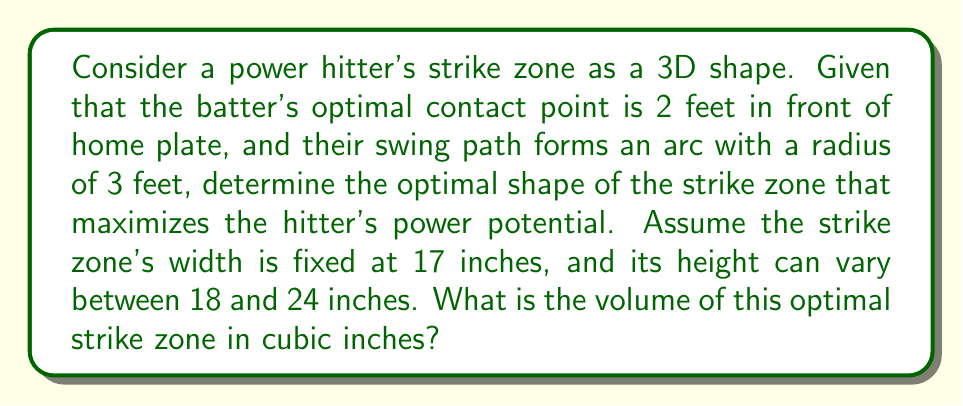Provide a solution to this math problem. To solve this problem, we need to consider the geometry of the swing and how it intersects with the strike zone. Let's break it down step-by-step:

1) The swing path forms an arc. This suggests that the optimal strike zone shape should conform to this arc to maximize contact potential.

2) We can model the strike zone as a segment of a torus (donut shape) that intersects with the swing arc.

3) The inner radius of the torus is 2 feet (distance to optimal contact point), and the tube radius is determined by the height of the strike zone.

4) To maximize power, we want to use the maximum allowed height of 24 inches (2 feet).

5) The width of the strike zone (17 inches) represents the angular section of the torus we're considering.

6) To calculate the volume, we need to find the volume of the toroidal segment:

   $$V = 2\pi^2 R r^2 \left(\frac{\theta}{360^\circ}\right)$$

   Where:
   $R$ = inner radius of the torus (2 feet)
   $r$ = tube radius (1 foot, half of the 24-inch height)
   $\theta$ = central angle subtended by the 17-inch width

7) To find $\theta$, we use the arc length formula:
   $$s = R\theta$$
   $$17 \text{ inches} = 24 \text{ inches} \cdot \theta$$
   $$\theta = \frac{17}{24} \text{ radians} \approx 0.7083 \text{ radians} \approx 40.58^\circ$$

8) Now we can calculate the volume:
   $$V = 2\pi^2 \cdot 2 \cdot 1^2 \cdot \left(\frac{40.58}{360}\right)$$
   $$V \approx 1.4164 \text{ cubic feet}$$

9) Convert to cubic inches:
   $$V \approx 1.4164 \cdot 12^3 = 2446.53 \text{ cubic inches}$$

[asy]
import three;

size(200);
currentprojection=perspective(6,3,2);

// Draw torus
real R = 2, r = 1;
triple f(pair t) {return ((R+r*cos(t.y))*cos(t.x),(R+r*cos(t.y))*sin(t.x),r*sin(t.y));}
surface s=surface(f,(0,0),(pi/4,2pi),8,8,Spline);
draw(s,paleblue+opacity(.5));

// Draw strike zone segment
path3 p=arc((R,0,0),r,90,270);
draw(rotate(0,0,20)*p,red+linewidth(2));
draw(rotate(0,0,-20)*p,red+linewidth(2));

// Draw swing arc
draw(arc((0,0,0),3,60,120,24),blue+linewidth(2));

// Labels
label("Strike Zone",(-1.5,1.5,0.5),red);
label("Swing Arc",(0,-2.5,-1),blue);
[/asy]
Answer: The optimal strike zone for a power hitter under the given conditions is approximately 2446.53 cubic inches. 